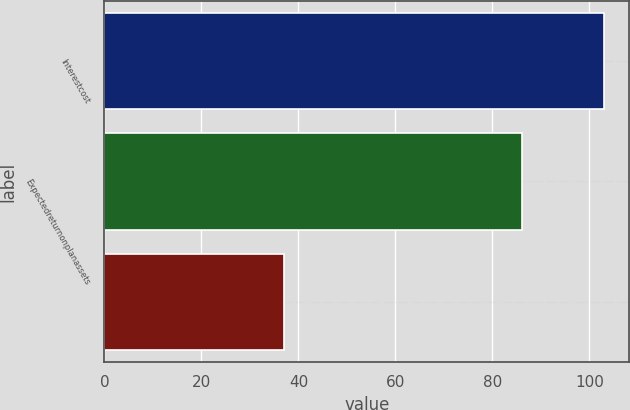Convert chart to OTSL. <chart><loc_0><loc_0><loc_500><loc_500><bar_chart><fcel>Interestcost<fcel>Expectedreturnonplanassets<fcel>Unnamed: 2<nl><fcel>103<fcel>86<fcel>37<nl></chart> 